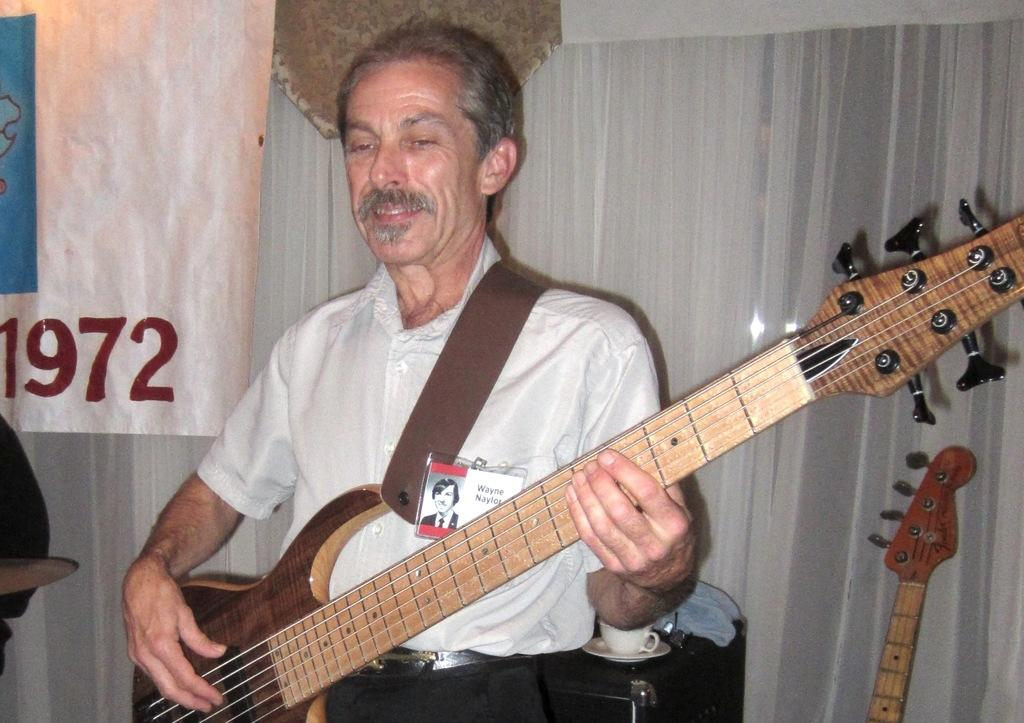What is the main subject of the image? There is a person in the image. What is the person wearing? The person is wearing a white color shirt. What activity is the person engaged in? The person is playing a guitar. What can be seen in the background of the image? There is a white color curtain in the background of the image. What channel is the person watching on the guitar? The image does not show the person watching a channel or using a guitar for that purpose. The person is playing the guitar as an activity. 